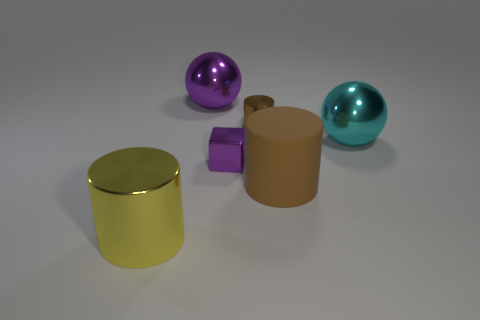Is the number of big purple balls greater than the number of large blue spheres?
Make the answer very short. Yes. There is a big ball that is to the left of the large cyan ball; is there a brown object that is behind it?
Make the answer very short. No. There is another large thing that is the same shape as the large matte thing; what is its color?
Make the answer very short. Yellow. Is there any other thing that is the same shape as the large yellow thing?
Make the answer very short. Yes. There is a small block that is the same material as the large yellow cylinder; what is its color?
Your answer should be very brief. Purple. There is a small object in front of the thing that is to the right of the brown rubber cylinder; are there any big cylinders that are behind it?
Your answer should be very brief. No. Is the number of blocks that are on the left side of the tiny brown metal thing less than the number of metal things that are in front of the big metallic cylinder?
Your answer should be very brief. No. How many big things have the same material as the tiny cylinder?
Provide a short and direct response. 3. There is a brown metallic cylinder; does it have the same size as the purple object on the left side of the metal block?
Provide a succinct answer. No. There is a big cylinder that is the same color as the small cylinder; what is its material?
Ensure brevity in your answer.  Rubber. 